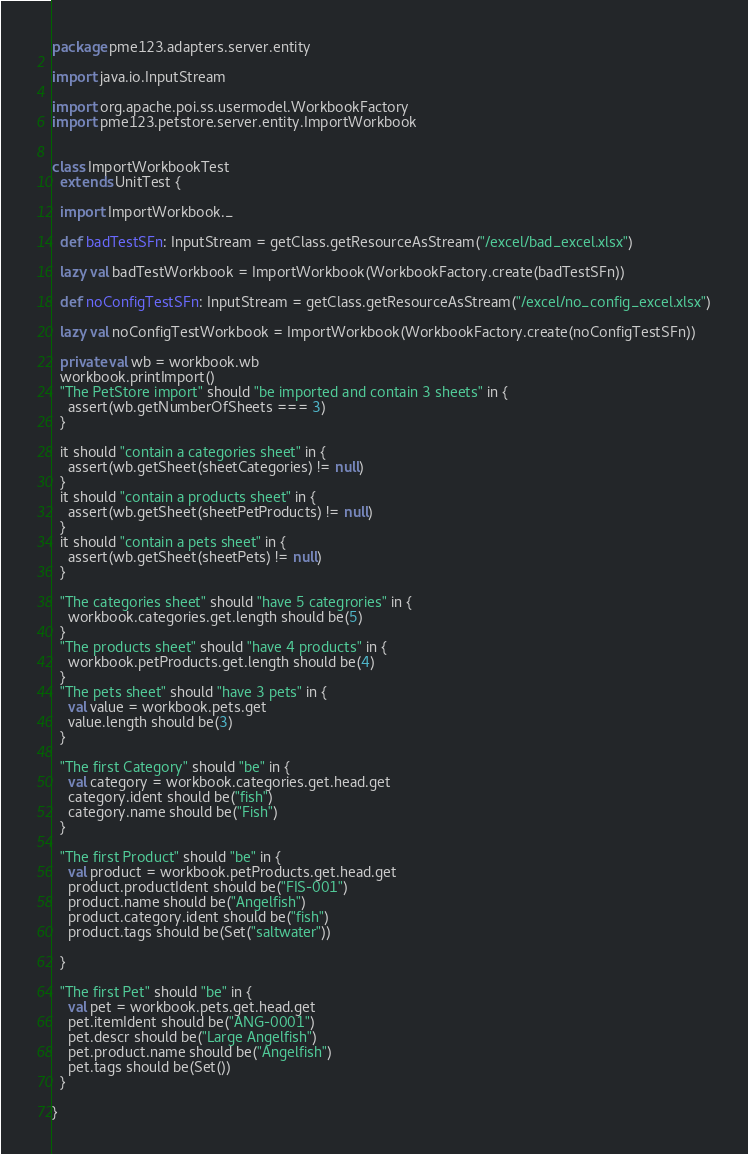Convert code to text. <code><loc_0><loc_0><loc_500><loc_500><_Scala_>package pme123.adapters.server.entity

import java.io.InputStream

import org.apache.poi.ss.usermodel.WorkbookFactory
import pme123.petstore.server.entity.ImportWorkbook


class ImportWorkbookTest
  extends UnitTest {

  import ImportWorkbook._

  def badTestSFn: InputStream = getClass.getResourceAsStream("/excel/bad_excel.xlsx")

  lazy val badTestWorkbook = ImportWorkbook(WorkbookFactory.create(badTestSFn))

  def noConfigTestSFn: InputStream = getClass.getResourceAsStream("/excel/no_config_excel.xlsx")

  lazy val noConfigTestWorkbook = ImportWorkbook(WorkbookFactory.create(noConfigTestSFn))

  private val wb = workbook.wb
  workbook.printImport()
  "The PetStore import" should "be imported and contain 3 sheets" in {
    assert(wb.getNumberOfSheets === 3)
  }

  it should "contain a categories sheet" in {
    assert(wb.getSheet(sheetCategories) != null)
  }
  it should "contain a products sheet" in {
    assert(wb.getSheet(sheetPetProducts) != null)
  }
  it should "contain a pets sheet" in {
    assert(wb.getSheet(sheetPets) != null)
  }

  "The categories sheet" should "have 5 categrories" in {
    workbook.categories.get.length should be(5)
  }
  "The products sheet" should "have 4 products" in {
    workbook.petProducts.get.length should be(4)
  }
  "The pets sheet" should "have 3 pets" in {
    val value = workbook.pets.get
    value.length should be(3)
  }

  "The first Category" should "be" in {
    val category = workbook.categories.get.head.get
    category.ident should be("fish")
    category.name should be("Fish")
  }

  "The first Product" should "be" in {
    val product = workbook.petProducts.get.head.get
    product.productIdent should be("FIS-001")
    product.name should be("Angelfish")
    product.category.ident should be("fish")
    product.tags should be(Set("saltwater"))

  }

  "The first Pet" should "be" in {
    val pet = workbook.pets.get.head.get
    pet.itemIdent should be("ANG-0001")
    pet.descr should be("Large Angelfish")
    pet.product.name should be("Angelfish")
    pet.tags should be(Set())
  }

}
</code> 